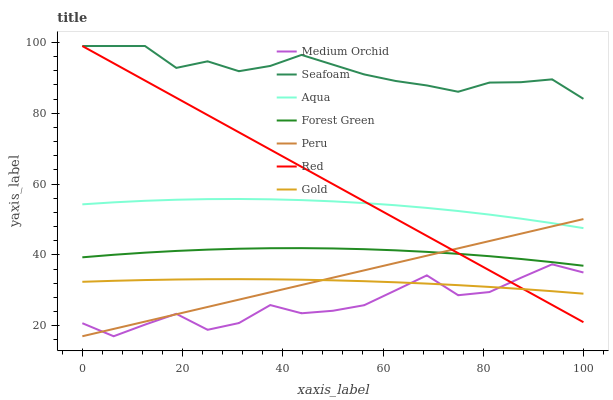Does Medium Orchid have the minimum area under the curve?
Answer yes or no. Yes. Does Seafoam have the maximum area under the curve?
Answer yes or no. Yes. Does Aqua have the minimum area under the curve?
Answer yes or no. No. Does Aqua have the maximum area under the curve?
Answer yes or no. No. Is Red the smoothest?
Answer yes or no. Yes. Is Medium Orchid the roughest?
Answer yes or no. Yes. Is Aqua the smoothest?
Answer yes or no. No. Is Aqua the roughest?
Answer yes or no. No. Does Medium Orchid have the lowest value?
Answer yes or no. Yes. Does Aqua have the lowest value?
Answer yes or no. No. Does Red have the highest value?
Answer yes or no. Yes. Does Medium Orchid have the highest value?
Answer yes or no. No. Is Medium Orchid less than Forest Green?
Answer yes or no. Yes. Is Aqua greater than Medium Orchid?
Answer yes or no. Yes. Does Medium Orchid intersect Peru?
Answer yes or no. Yes. Is Medium Orchid less than Peru?
Answer yes or no. No. Is Medium Orchid greater than Peru?
Answer yes or no. No. Does Medium Orchid intersect Forest Green?
Answer yes or no. No. 